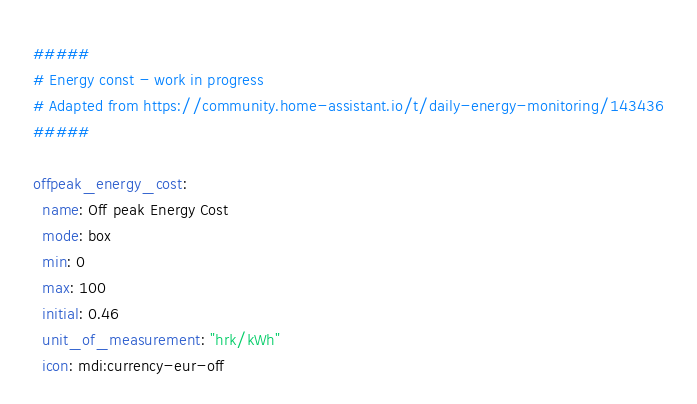<code> <loc_0><loc_0><loc_500><loc_500><_YAML_>#####
# Energy const - work in progress
# Adapted from https://community.home-assistant.io/t/daily-energy-monitoring/143436
#####

offpeak_energy_cost:
  name: Off peak Energy Cost
  mode: box
  min: 0
  max: 100
  initial: 0.46
  unit_of_measurement: "hrk/kWh"
  icon: mdi:currency-eur-off
</code> 